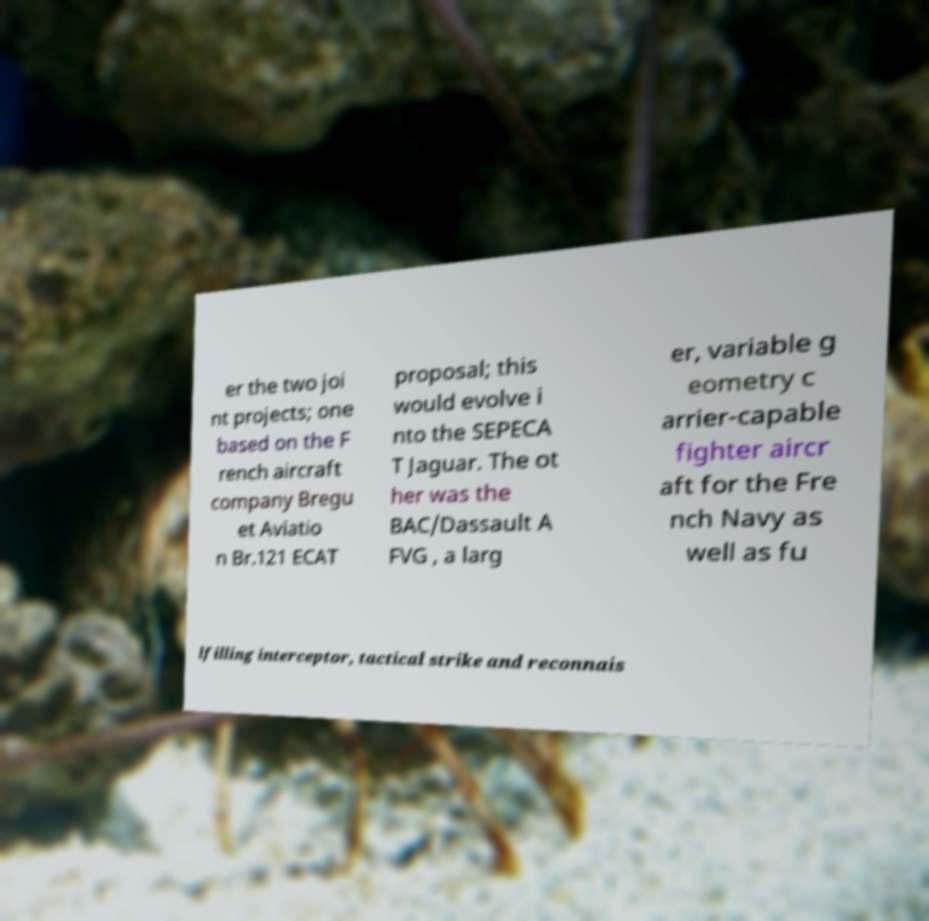Could you assist in decoding the text presented in this image and type it out clearly? er the two joi nt projects; one based on the F rench aircraft company Bregu et Aviatio n Br.121 ECAT proposal; this would evolve i nto the SEPECA T Jaguar. The ot her was the BAC/Dassault A FVG , a larg er, variable g eometry c arrier-capable fighter aircr aft for the Fre nch Navy as well as fu lfilling interceptor, tactical strike and reconnais 